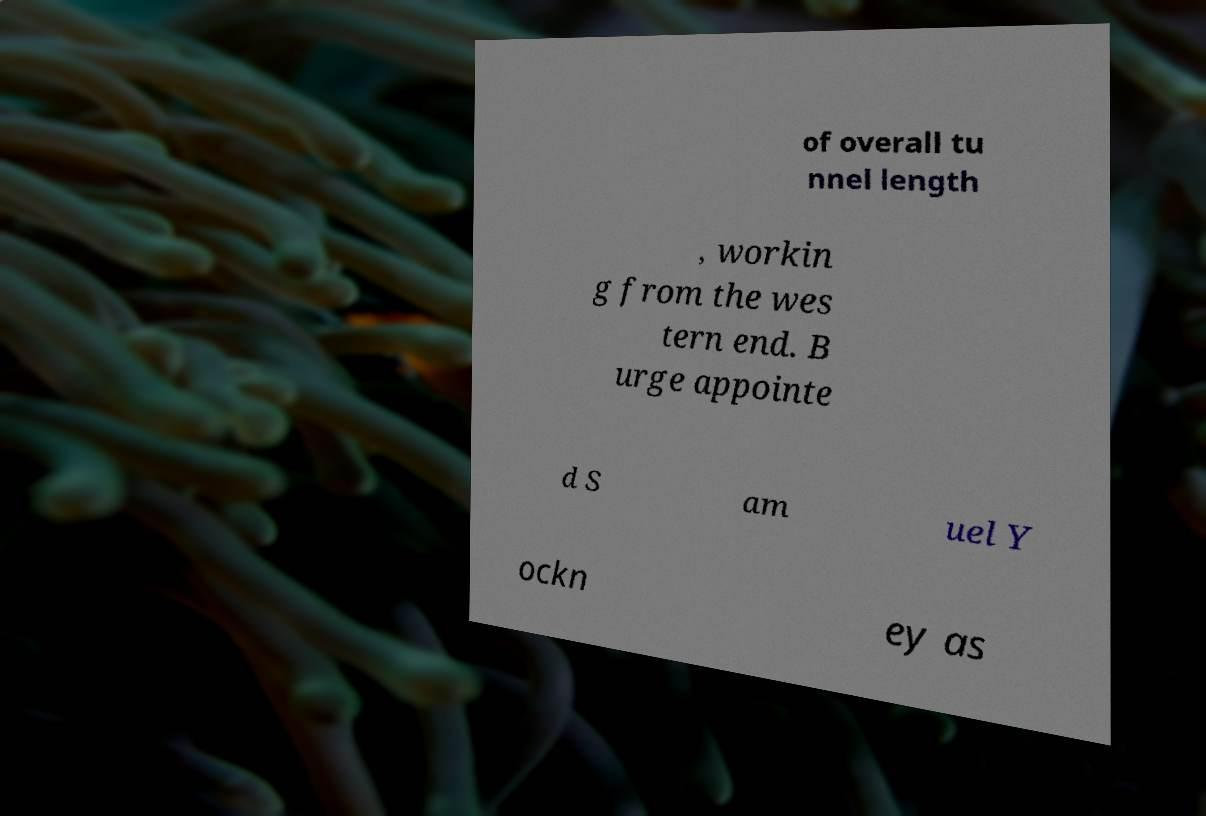What messages or text are displayed in this image? I need them in a readable, typed format. of overall tu nnel length , workin g from the wes tern end. B urge appointe d S am uel Y ockn ey as 